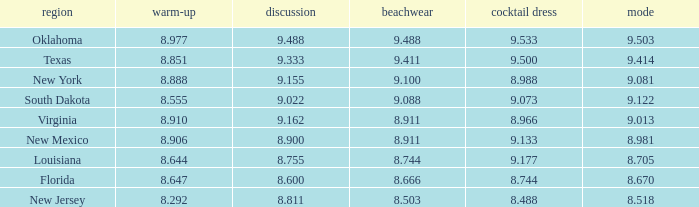 what's the preliminaries where evening gown is 8.988 8.888. 